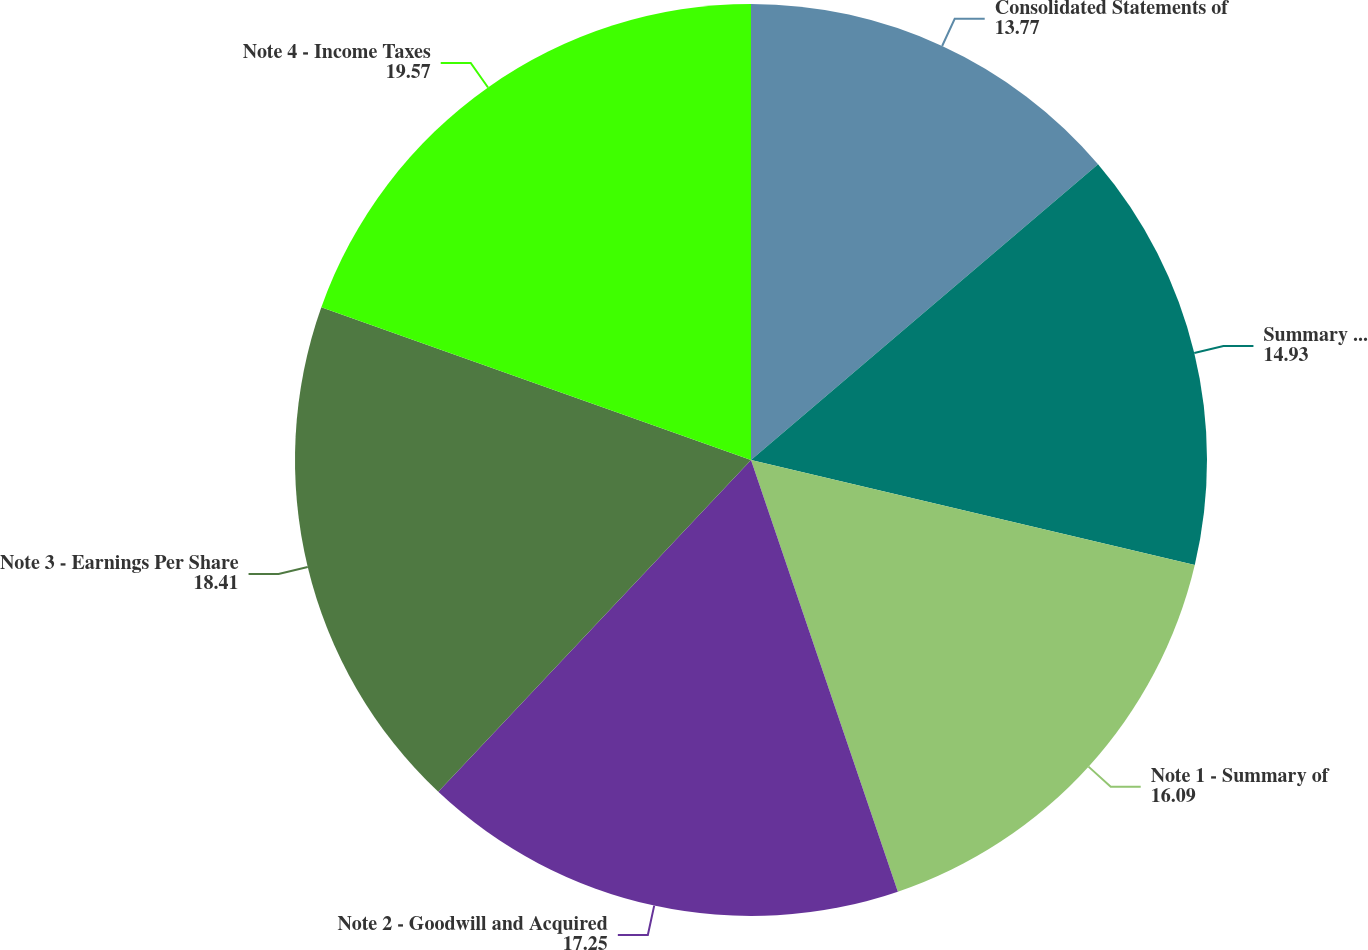<chart> <loc_0><loc_0><loc_500><loc_500><pie_chart><fcel>Consolidated Statements of<fcel>Summary of Business Segment<fcel>Note 1 - Summary of<fcel>Note 2 - Goodwill and Acquired<fcel>Note 3 - Earnings Per Share<fcel>Note 4 - Income Taxes<nl><fcel>13.77%<fcel>14.93%<fcel>16.09%<fcel>17.25%<fcel>18.41%<fcel>19.57%<nl></chart> 